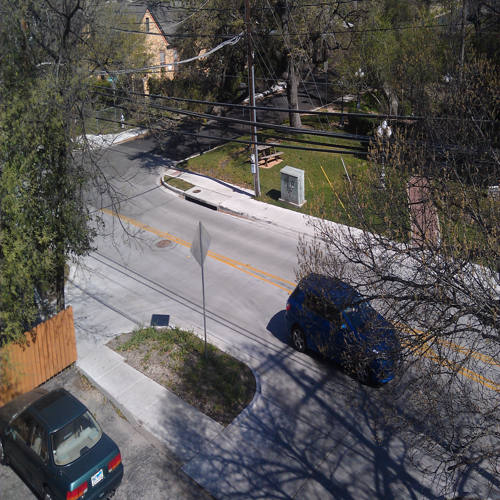Can the details and textures of the subject be recognized and distinguished? Yes, the details and textures in the image are clear and easily recognizable. The resolution allows for distinct visual understanding of various elements, such as the textures of the trees and the construction of the vehicles and buildings. 